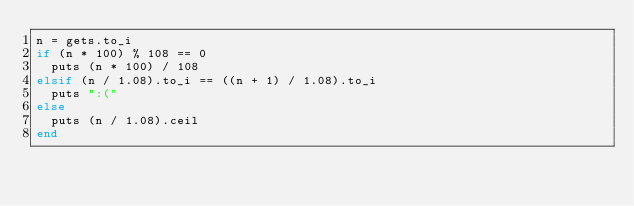<code> <loc_0><loc_0><loc_500><loc_500><_Ruby_>n = gets.to_i
if (n * 100) % 108 == 0
  puts (n * 100) / 108
elsif (n / 1.08).to_i == ((n + 1) / 1.08).to_i
  puts ":("
else
  puts (n / 1.08).ceil
end
</code> 